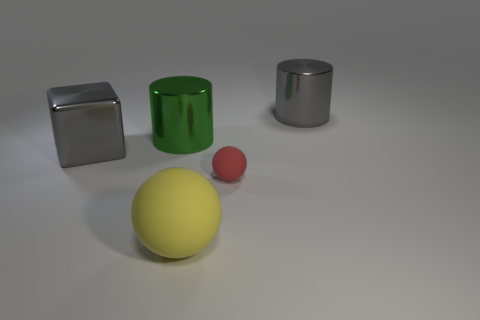Add 5 gray things. How many objects exist? 10 Subtract all red balls. How many balls are left? 1 Subtract 1 gray blocks. How many objects are left? 4 Subtract all blocks. How many objects are left? 4 Subtract 1 blocks. How many blocks are left? 0 Subtract all red balls. Subtract all blue cylinders. How many balls are left? 1 Subtract all blue balls. How many gray cylinders are left? 1 Subtract all balls. Subtract all gray things. How many objects are left? 1 Add 4 metal things. How many metal things are left? 7 Add 3 gray blocks. How many gray blocks exist? 4 